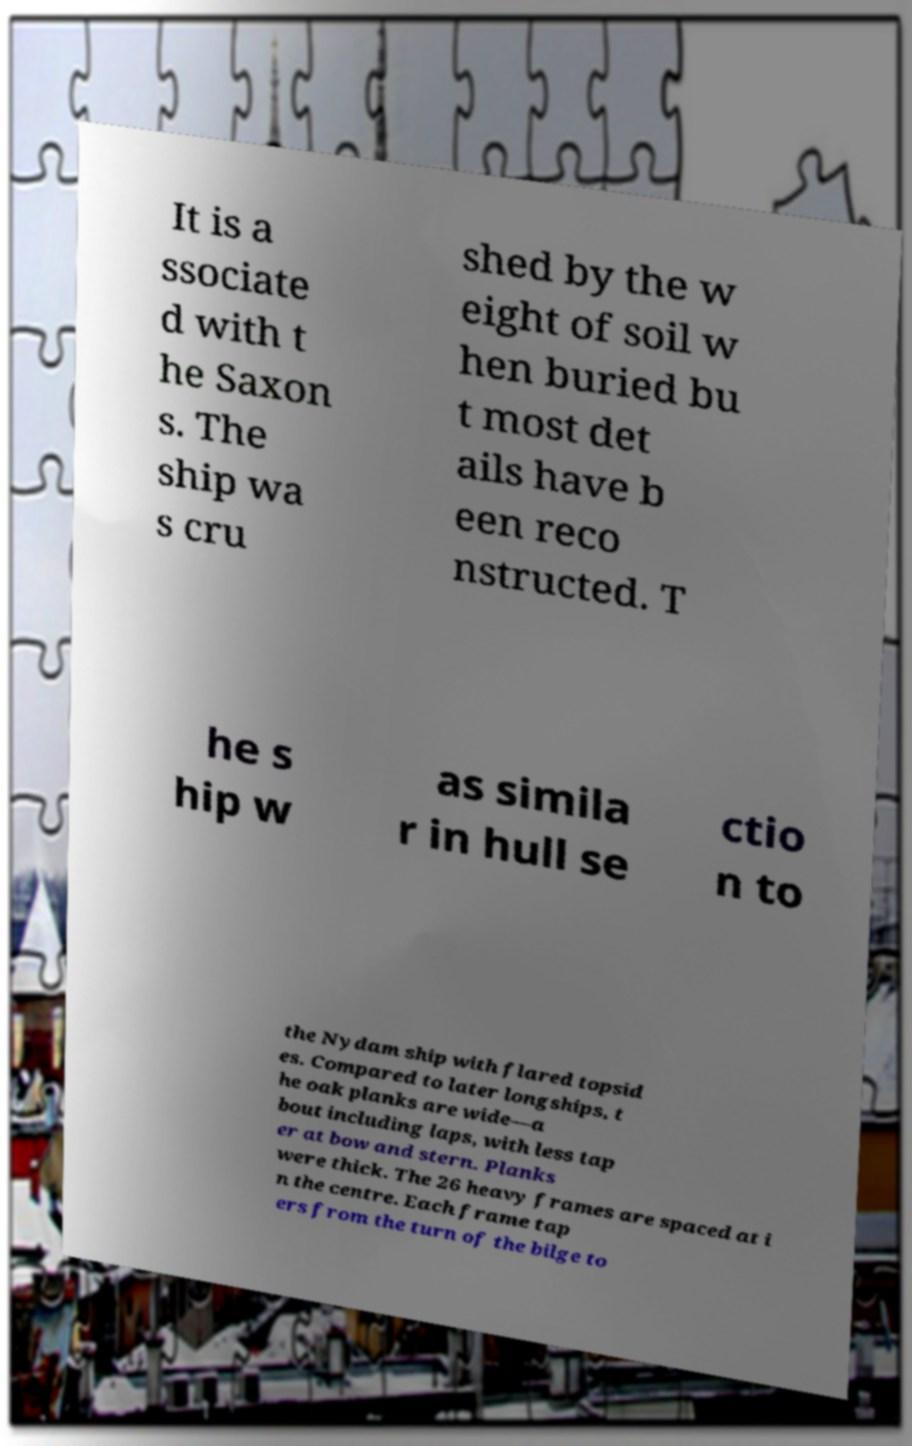Please read and relay the text visible in this image. What does it say? It is a ssociate d with t he Saxon s. The ship wa s cru shed by the w eight of soil w hen buried bu t most det ails have b een reco nstructed. T he s hip w as simila r in hull se ctio n to the Nydam ship with flared topsid es. Compared to later longships, t he oak planks are wide—a bout including laps, with less tap er at bow and stern. Planks were thick. The 26 heavy frames are spaced at i n the centre. Each frame tap ers from the turn of the bilge to 